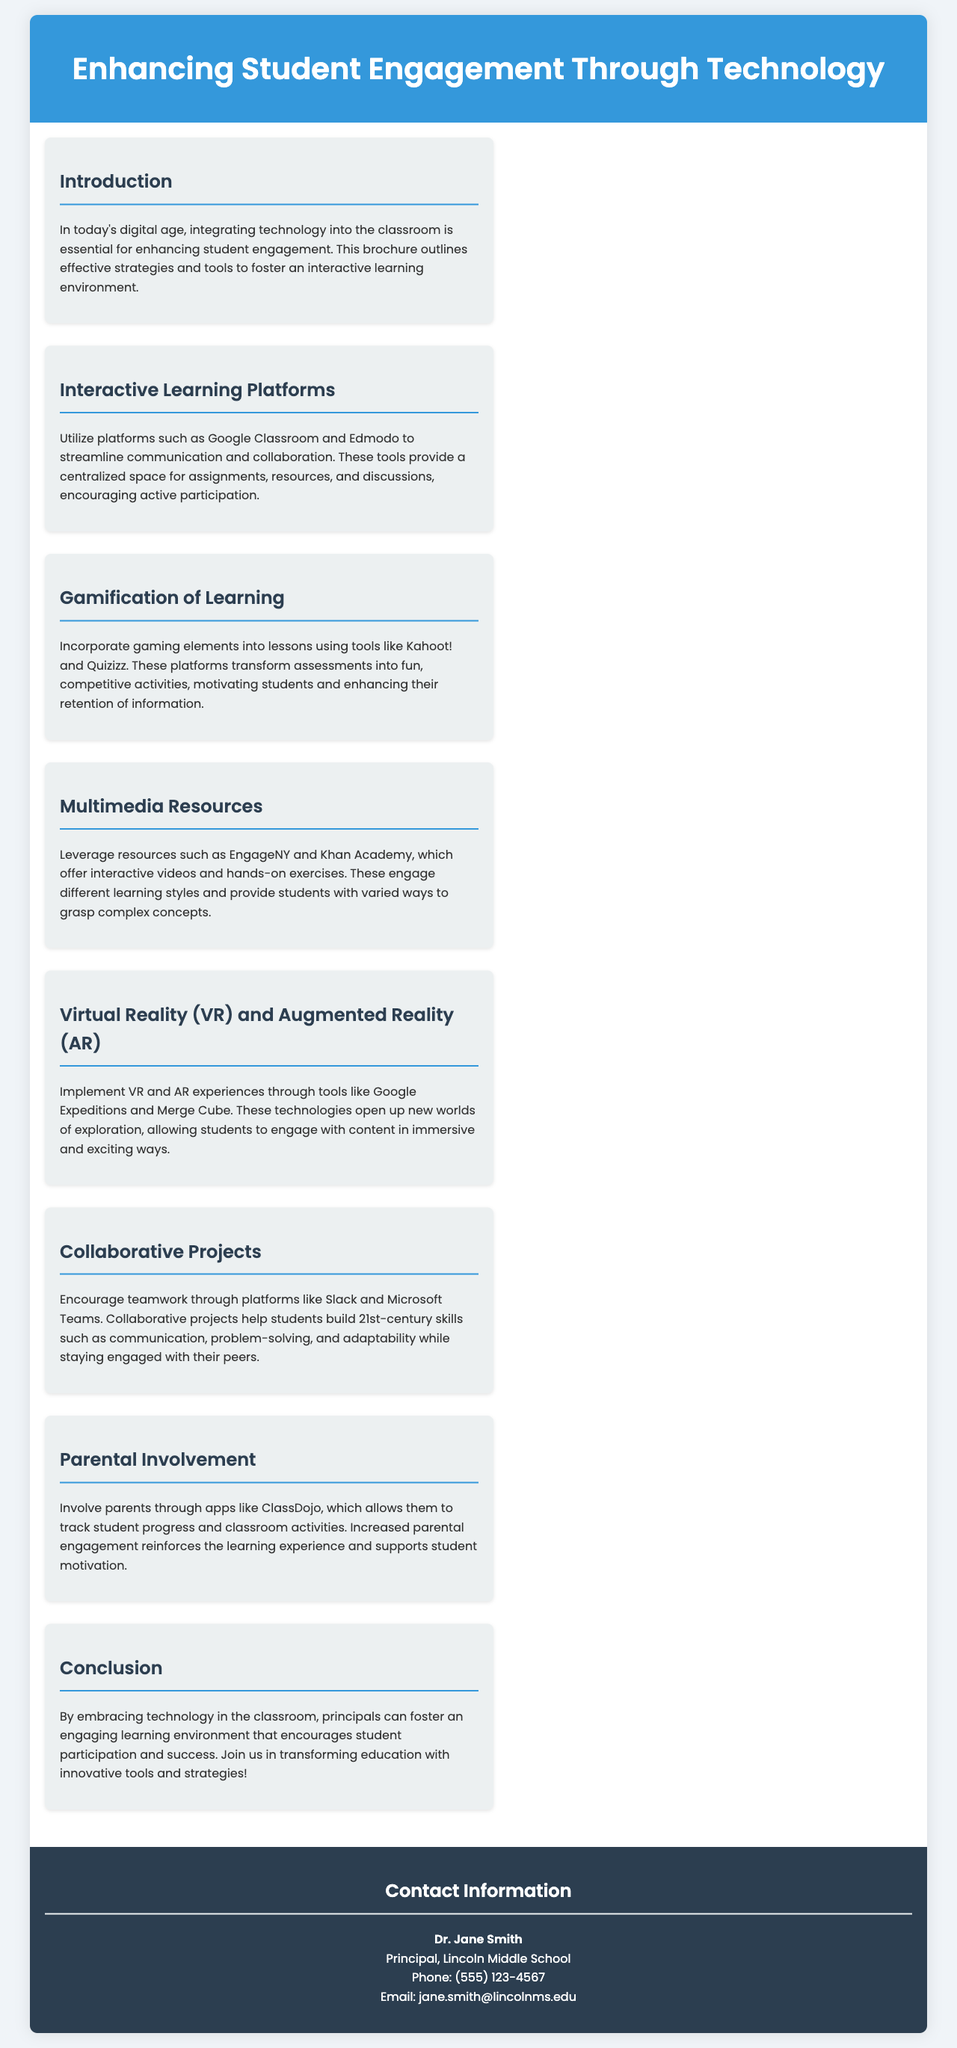What is the title of the brochure? The title of the brochure is prominently displayed at the top of the document.
Answer: Enhancing Student Engagement Through Technology Who is the author of the brochure? The author is mentioned in the contact information section at the end of the document.
Answer: Dr. Jane Smith What platform is mentioned for interactive learning? This platform is listed under the section for Interactive Learning Platforms.
Answer: Google Classroom Which gamification tool is referenced? The gamification tool is included in the section about Gamification of Learning.
Answer: Kahoot! What type of resources do EngageNY and Khan Academy provide? This is explained in the section discussing Multimedia Resources.
Answer: Interactive videos and hands-on exercises What technology can be used for virtual experiences? This is specified in the section about Virtual Reality (VR) and Augmented Reality (AR).
Answer: Google Expeditions How does ClassDojo help parents? This is described in the Parental Involvement section of the brochure.
Answer: Track student progress What is emphasized in the Conclusion section? The conclusion summarizes the overall purpose and goal of the brochure.
Answer: Innovative tools and strategies What section follows Interactive Learning Platforms? The structure of the brochure allows for easy navigation between sections.
Answer: Gamification of Learning 